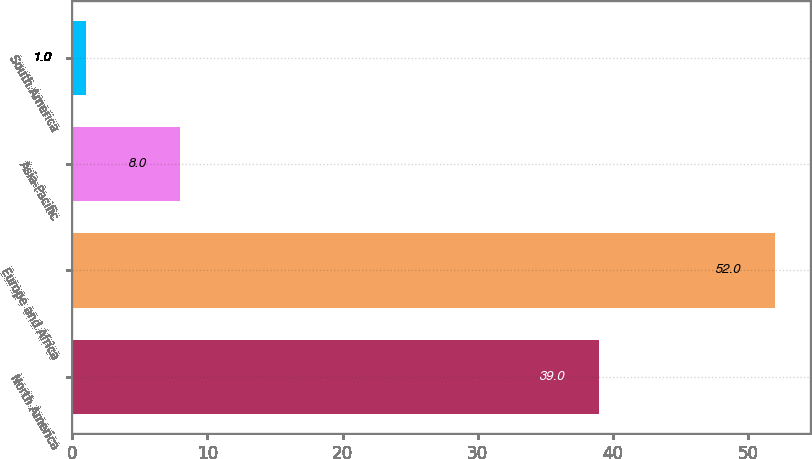Convert chart. <chart><loc_0><loc_0><loc_500><loc_500><bar_chart><fcel>North America<fcel>Europe and Africa<fcel>Asia-Pacific<fcel>South America<nl><fcel>39<fcel>52<fcel>8<fcel>1<nl></chart> 